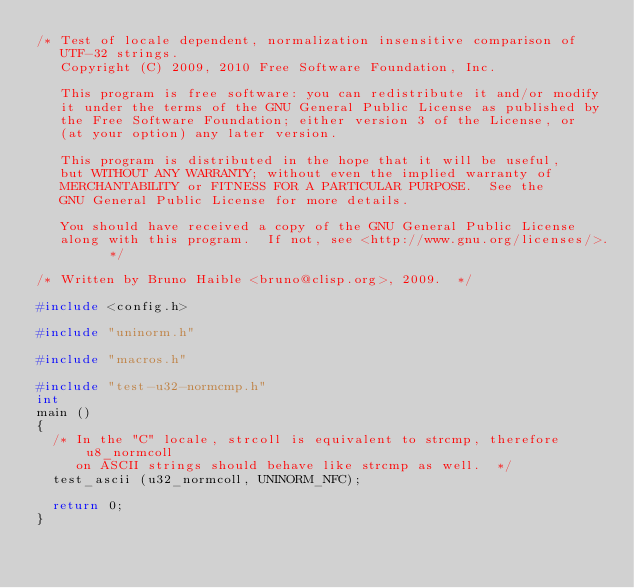Convert code to text. <code><loc_0><loc_0><loc_500><loc_500><_C_>/* Test of locale dependent, normalization insensitive comparison of
   UTF-32 strings.
   Copyright (C) 2009, 2010 Free Software Foundation, Inc.

   This program is free software: you can redistribute it and/or modify
   it under the terms of the GNU General Public License as published by
   the Free Software Foundation; either version 3 of the License, or
   (at your option) any later version.

   This program is distributed in the hope that it will be useful,
   but WITHOUT ANY WARRANTY; without even the implied warranty of
   MERCHANTABILITY or FITNESS FOR A PARTICULAR PURPOSE.  See the
   GNU General Public License for more details.

   You should have received a copy of the GNU General Public License
   along with this program.  If not, see <http://www.gnu.org/licenses/>.  */

/* Written by Bruno Haible <bruno@clisp.org>, 2009.  */

#include <config.h>

#include "uninorm.h"

#include "macros.h"

#include "test-u32-normcmp.h"
int
main ()
{
  /* In the "C" locale, strcoll is equivalent to strcmp, therefore u8_normcoll
     on ASCII strings should behave like strcmp as well.  */
  test_ascii (u32_normcoll, UNINORM_NFC);

  return 0;
}
</code> 